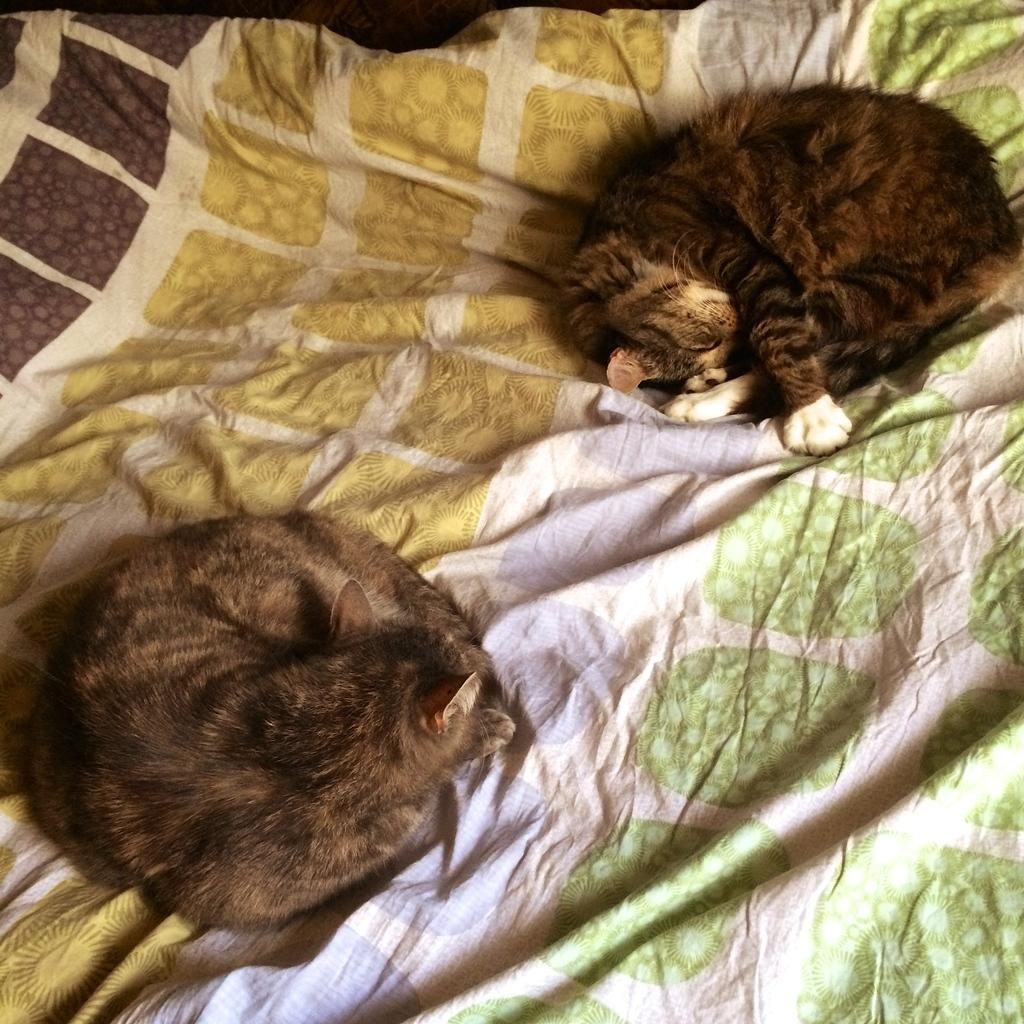How many cats are in the image? There are two cats in the image. Where are the cats located? The cats are on a bed. What colors do the cats have? The cats have brown, black, and white colors. What is the color of the blanket on the bed? The blanket on the bed has a different color. What is the best route for the cats to take to reach the kitchen from the bed? There is no information about the kitchen or a route in the image, so it cannot be determined. 